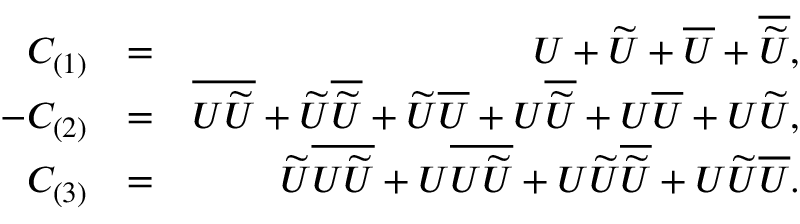<formula> <loc_0><loc_0><loc_500><loc_500>\begin{array} { r l r } { C _ { ( 1 ) } } & { = } & { U + \widetilde { U } + \overline { U } + \overline { { \widetilde { U } } } , } \\ { - C _ { ( 2 ) } } & { = } & { \overline { { U \widetilde { U } } } + \widetilde { U } \overline { { \widetilde { U } } } + \widetilde { U } \overline { U } + U \overline { { \widetilde { U } } } + U \overline { U } + U \widetilde { U } , } \\ { C _ { ( 3 ) } } & { = } & { \widetilde { U } \overline { { U \widetilde { U } } } + U \overline { { U \widetilde { U } } } + U \widetilde { U } \overline { { \widetilde { U } } } + U \widetilde { U } \overline { U } . } \end{array}</formula> 